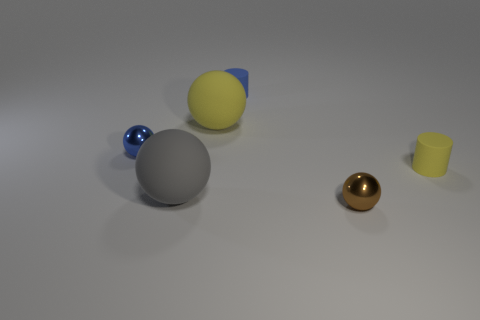Subtract all yellow balls. Subtract all blue cylinders. How many balls are left? 3 Add 3 cylinders. How many objects exist? 9 Subtract all balls. How many objects are left? 2 Add 1 big yellow spheres. How many big yellow spheres exist? 2 Subtract 0 gray cylinders. How many objects are left? 6 Subtract all red cubes. Subtract all big gray matte things. How many objects are left? 5 Add 3 large yellow matte balls. How many large yellow matte balls are left? 4 